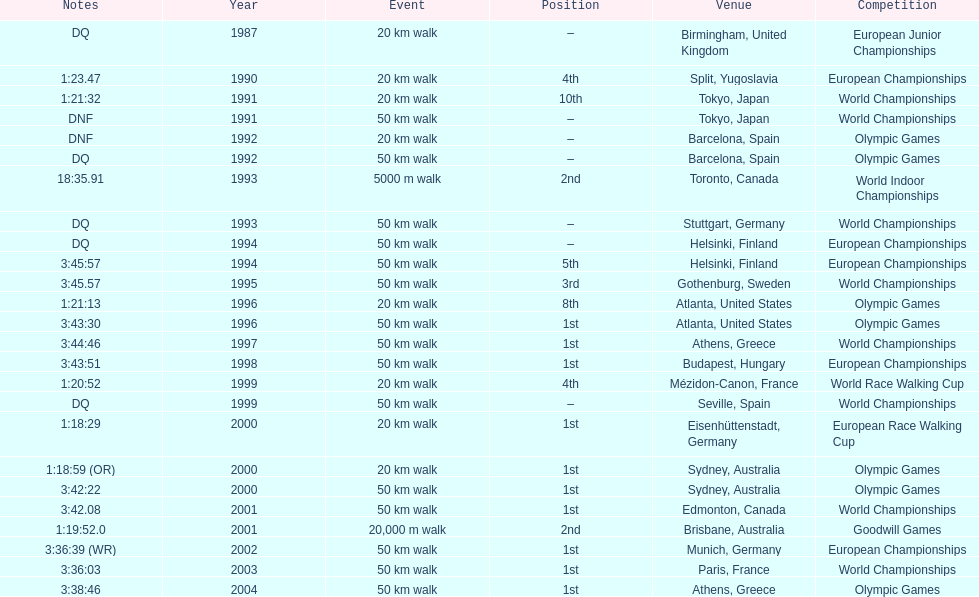In what year was korzeniowski's last competition? 2004. 